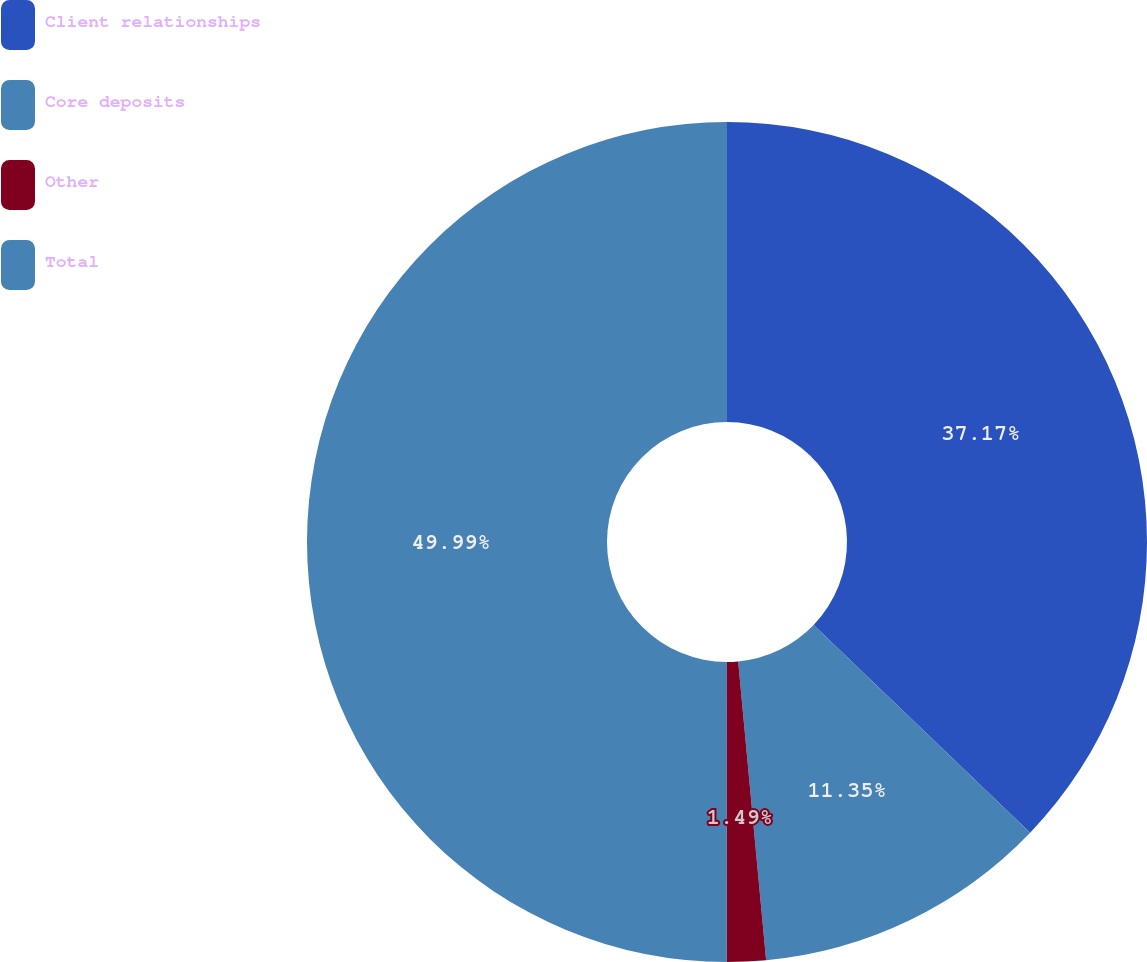Convert chart. <chart><loc_0><loc_0><loc_500><loc_500><pie_chart><fcel>Client relationships<fcel>Core deposits<fcel>Other<fcel>Total<nl><fcel>37.17%<fcel>11.35%<fcel>1.49%<fcel>50.0%<nl></chart> 